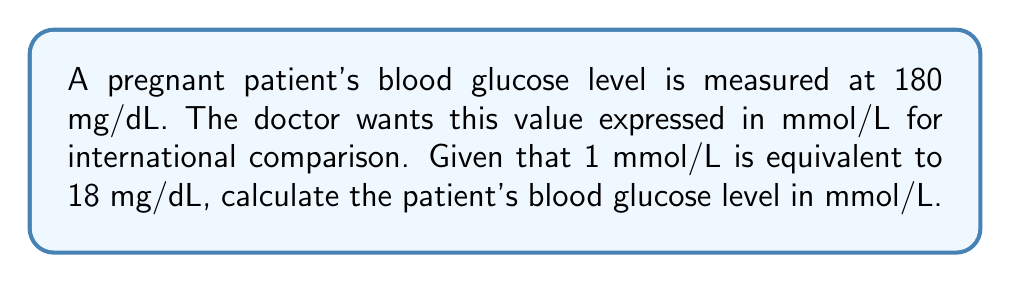Provide a solution to this math problem. To convert the blood glucose level from mg/dL to mmol/L, we need to use the given conversion factor:

1 mmol/L = 18 mg/dL

Let's set up a proportion to solve this problem:

$$\frac{1 \text{ mmol/L}}{18 \text{ mg/dL}} = \frac{x \text{ mmol/L}}{180 \text{ mg/dL}}$$

Where $x$ is the blood glucose level in mmol/L that we're trying to find.

Cross-multiply:

$$(1)(180) = (18)(x)$$

$$180 = 18x$$

Now, solve for $x$ by dividing both sides by 18:

$$x = \frac{180}{18} = 10$$

Therefore, the patient's blood glucose level is 10 mmol/L.
Answer: 10 mmol/L 